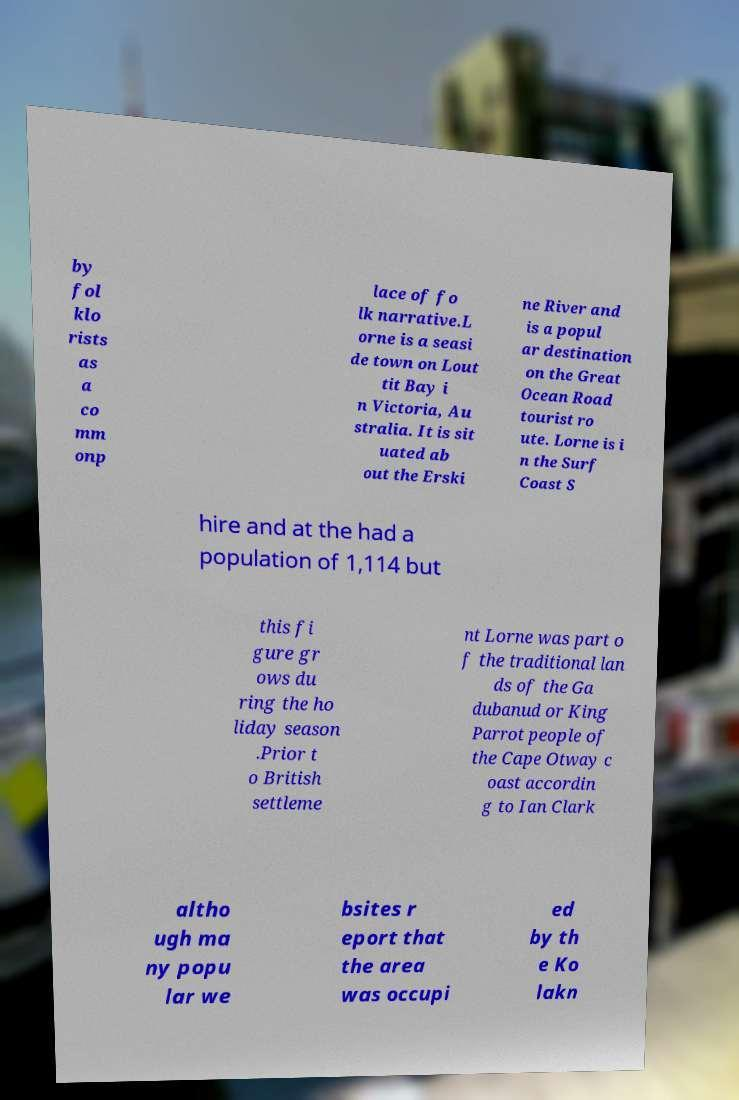I need the written content from this picture converted into text. Can you do that? by fol klo rists as a co mm onp lace of fo lk narrative.L orne is a seasi de town on Lout tit Bay i n Victoria, Au stralia. It is sit uated ab out the Erski ne River and is a popul ar destination on the Great Ocean Road tourist ro ute. Lorne is i n the Surf Coast S hire and at the had a population of 1,114 but this fi gure gr ows du ring the ho liday season .Prior t o British settleme nt Lorne was part o f the traditional lan ds of the Ga dubanud or King Parrot people of the Cape Otway c oast accordin g to Ian Clark altho ugh ma ny popu lar we bsites r eport that the area was occupi ed by th e Ko lakn 